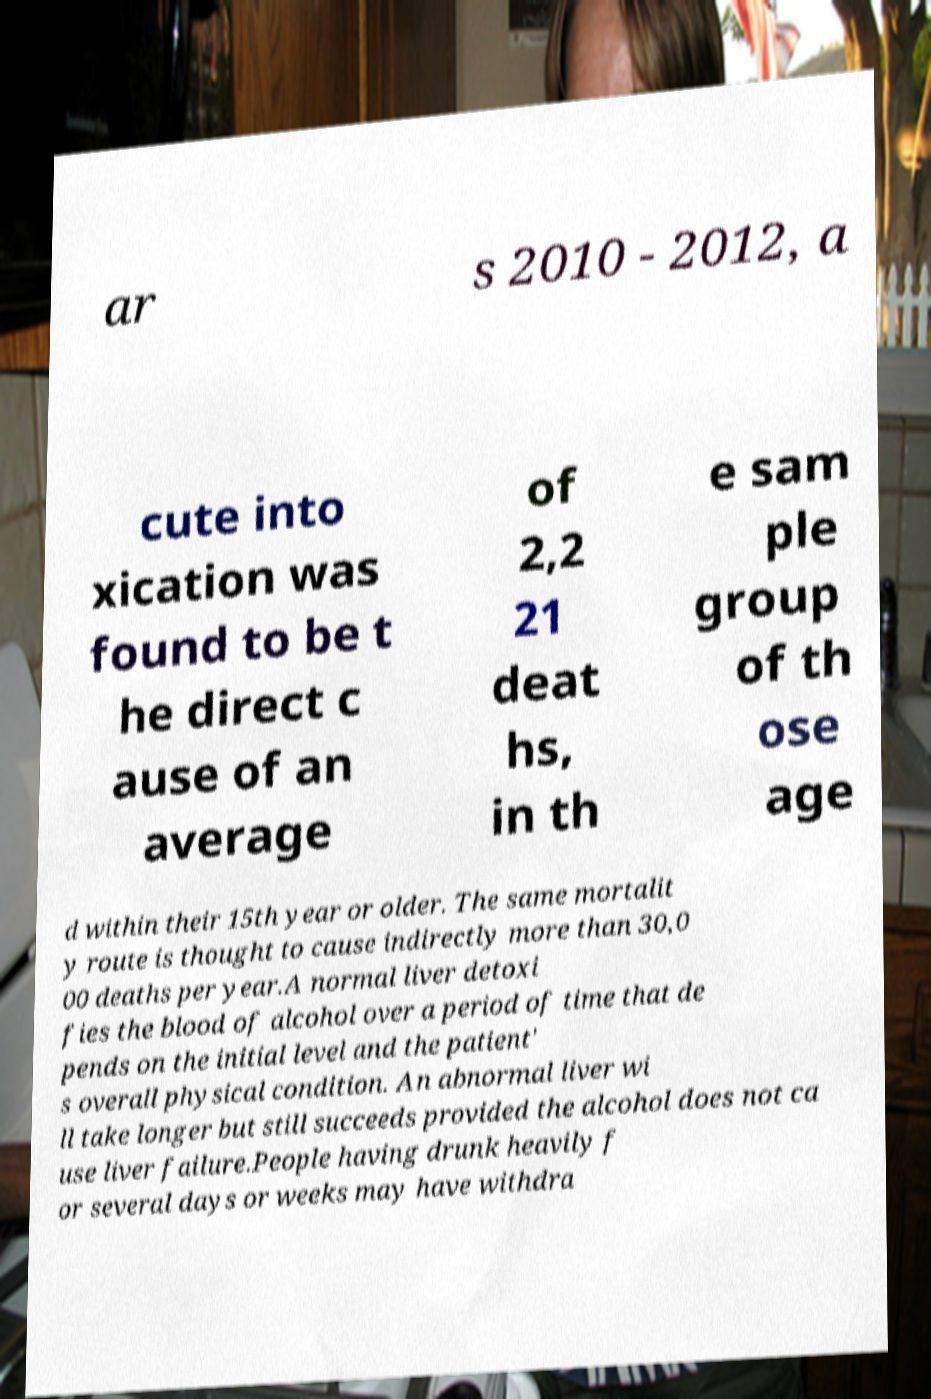Can you read and provide the text displayed in the image?This photo seems to have some interesting text. Can you extract and type it out for me? ar s 2010 - 2012, a cute into xication was found to be t he direct c ause of an average of 2,2 21 deat hs, in th e sam ple group of th ose age d within their 15th year or older. The same mortalit y route is thought to cause indirectly more than 30,0 00 deaths per year.A normal liver detoxi fies the blood of alcohol over a period of time that de pends on the initial level and the patient' s overall physical condition. An abnormal liver wi ll take longer but still succeeds provided the alcohol does not ca use liver failure.People having drunk heavily f or several days or weeks may have withdra 